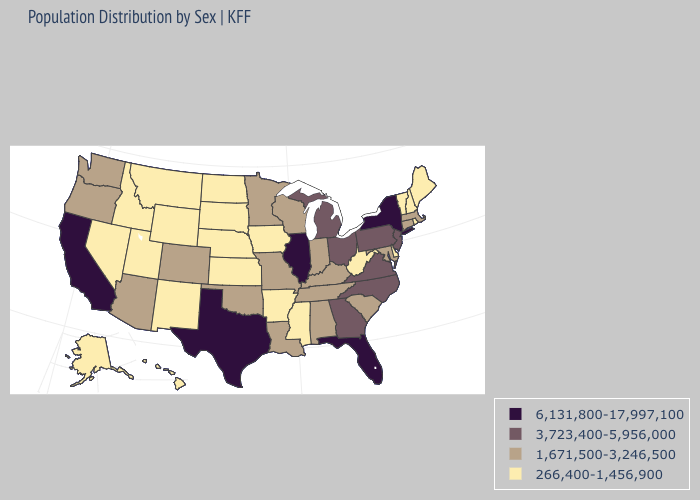What is the highest value in states that border Indiana?
Quick response, please. 6,131,800-17,997,100. Name the states that have a value in the range 266,400-1,456,900?
Concise answer only. Alaska, Arkansas, Delaware, Hawaii, Idaho, Iowa, Kansas, Maine, Mississippi, Montana, Nebraska, Nevada, New Hampshire, New Mexico, North Dakota, Rhode Island, South Dakota, Utah, Vermont, West Virginia, Wyoming. What is the value of Florida?
Give a very brief answer. 6,131,800-17,997,100. What is the highest value in states that border Utah?
Quick response, please. 1,671,500-3,246,500. Does the first symbol in the legend represent the smallest category?
Keep it brief. No. What is the highest value in states that border Wisconsin?
Concise answer only. 6,131,800-17,997,100. Does Illinois have the highest value in the USA?
Concise answer only. Yes. Which states hav the highest value in the South?
Concise answer only. Florida, Texas. What is the value of Hawaii?
Answer briefly. 266,400-1,456,900. What is the lowest value in the South?
Concise answer only. 266,400-1,456,900. Name the states that have a value in the range 6,131,800-17,997,100?
Be succinct. California, Florida, Illinois, New York, Texas. Among the states that border Michigan , which have the highest value?
Answer briefly. Ohio. What is the value of Ohio?
Be succinct. 3,723,400-5,956,000. Does the map have missing data?
Write a very short answer. No. Does Texas have the highest value in the USA?
Give a very brief answer. Yes. 